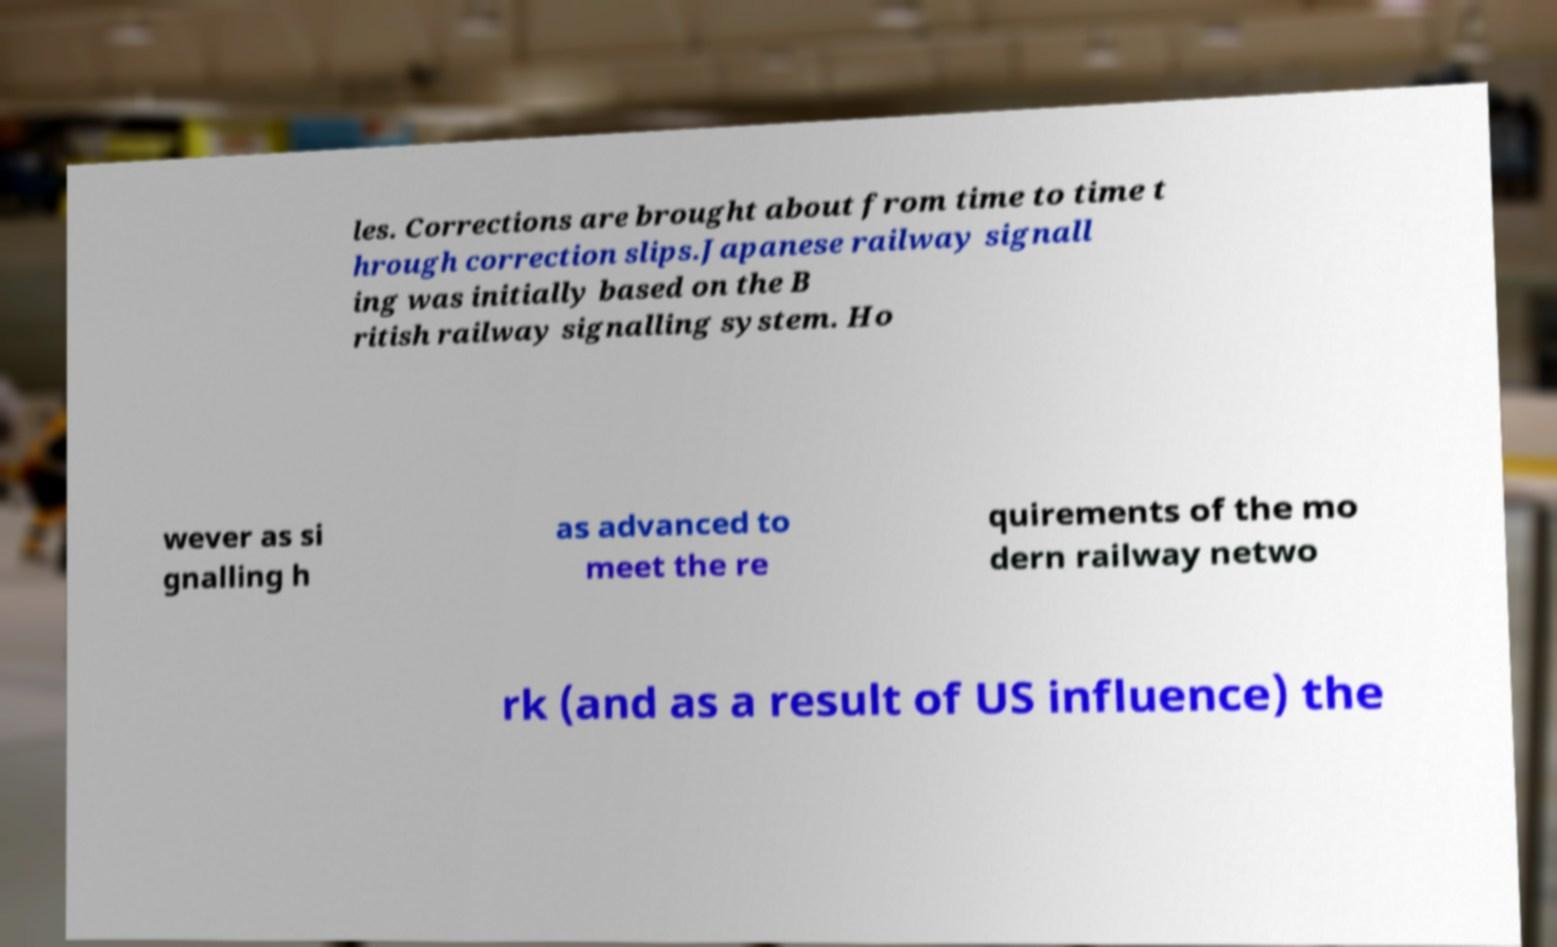I need the written content from this picture converted into text. Can you do that? les. Corrections are brought about from time to time t hrough correction slips.Japanese railway signall ing was initially based on the B ritish railway signalling system. Ho wever as si gnalling h as advanced to meet the re quirements of the mo dern railway netwo rk (and as a result of US influence) the 